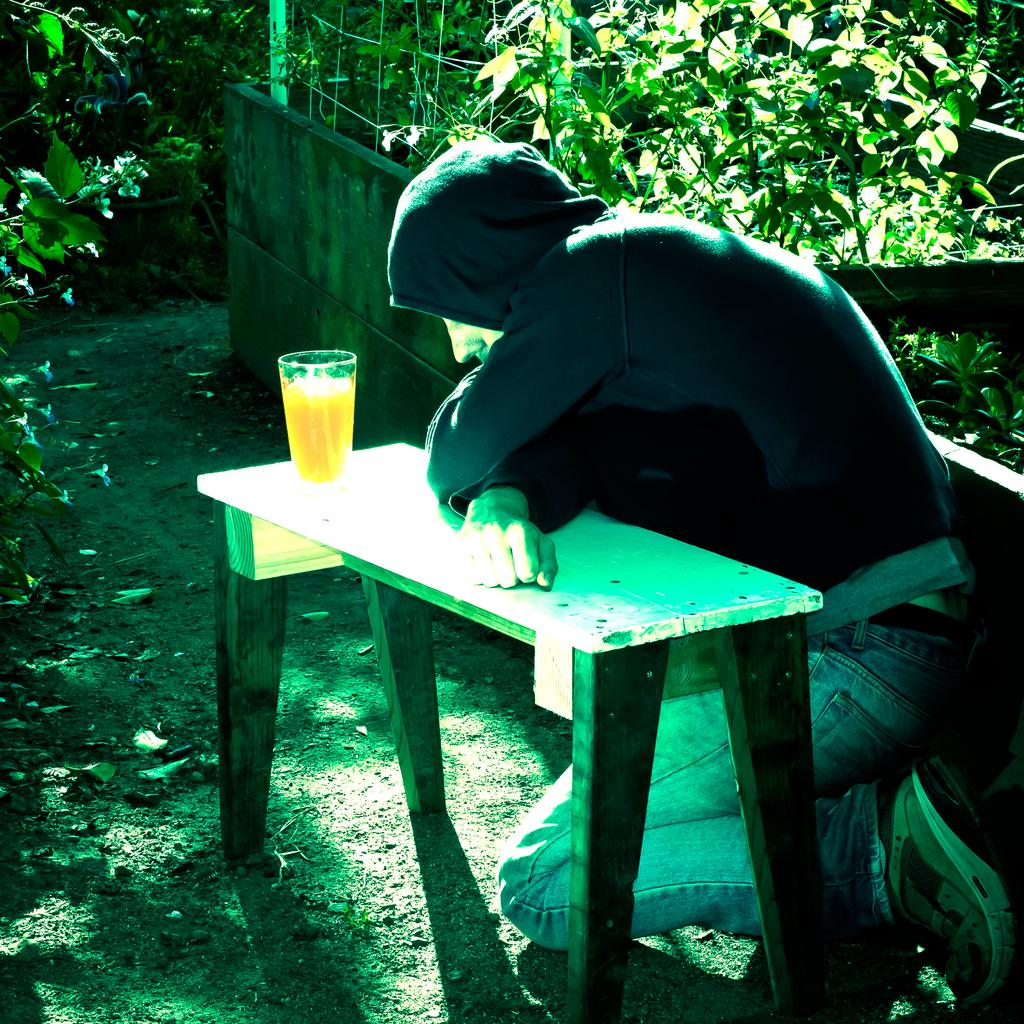Who or what is present in the image? There is a person in the image. Where is the person located in relation to other objects? The person is near a table. What can be seen on the table? There is a glass on the table. What can be seen in the background of the image? There are plants in the background of the image. What type of pot is the person using to reach an agreement in the image? There is no pot or agreement present in the image; it only features a person near a table with a glass and plants in the background. 